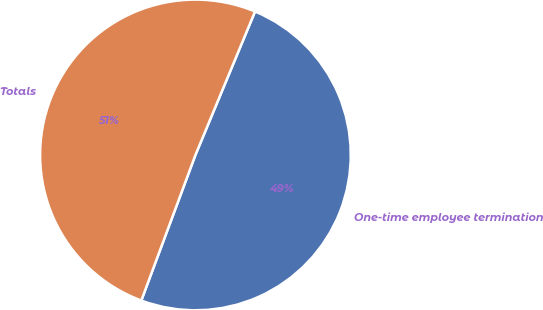Convert chart to OTSL. <chart><loc_0><loc_0><loc_500><loc_500><pie_chart><fcel>One-time employee termination<fcel>Totals<nl><fcel>49.4%<fcel>50.6%<nl></chart> 